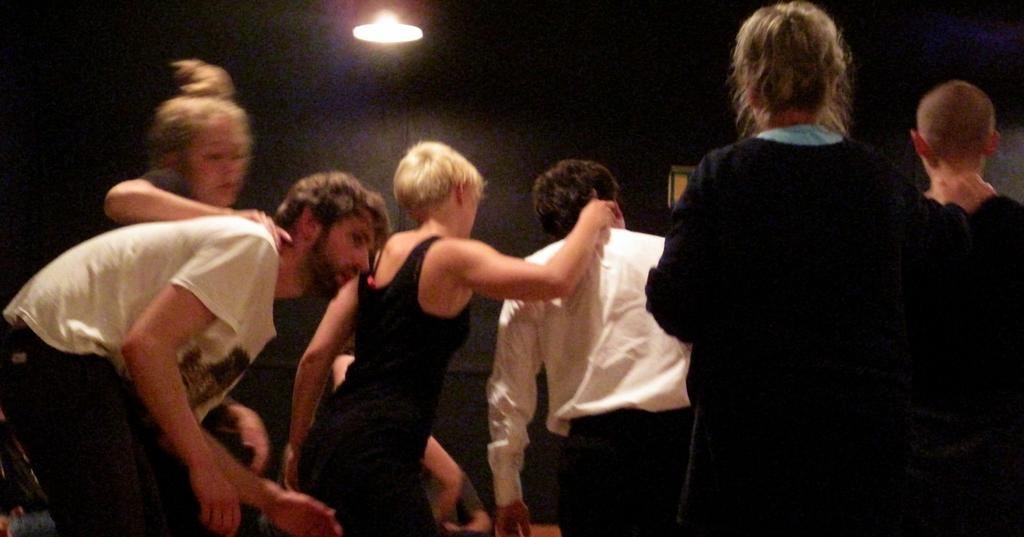Who or what can be seen in the image? There are people in the image. What is visible in the background of the image? There is a wall in the background of the image. What is located at the top of the image? There is a ceiling with light at the top of the image. Can you see any hills in the image? There are no hills visible in the image. Does the image prove the existence of an owl? There is no owl present in the image, so it cannot prove the existence of an owl. 